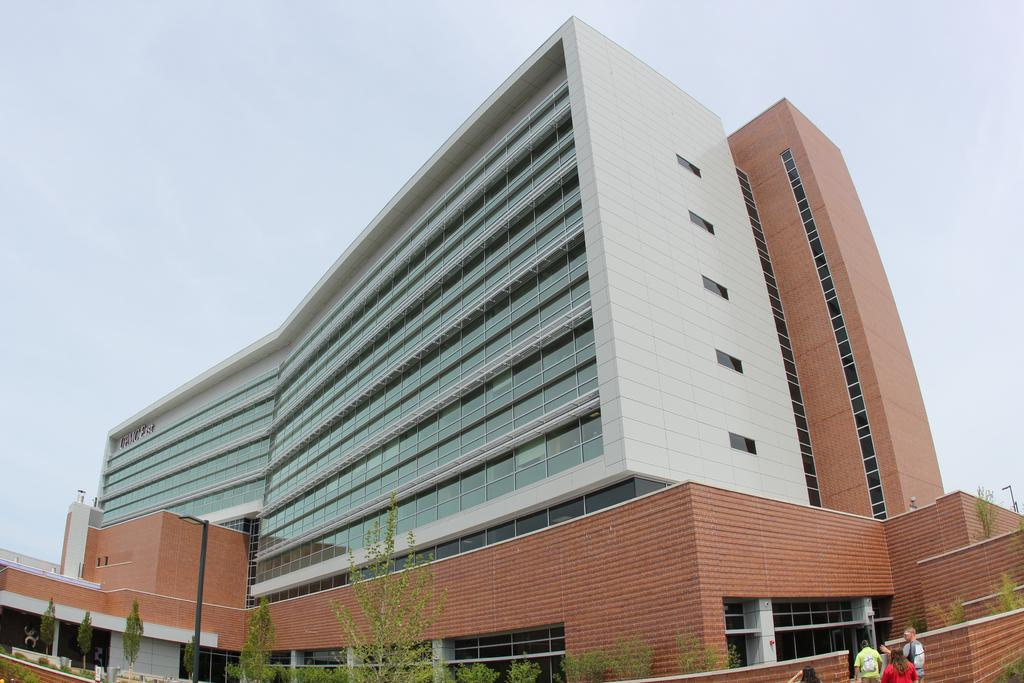What type of structure is depicted in the image? There is a tall building with windows in the image. What can be seen at the bottom of the image? There are plants at the bottom of the image. Where are the people located in the image? The people are standing near a wall on the right side of the image. How many planes can be seen flying over the building in the image? There are no planes visible in the image; it only shows a tall building with windows, plants at the bottom, and people standing near a wall on the right side. 